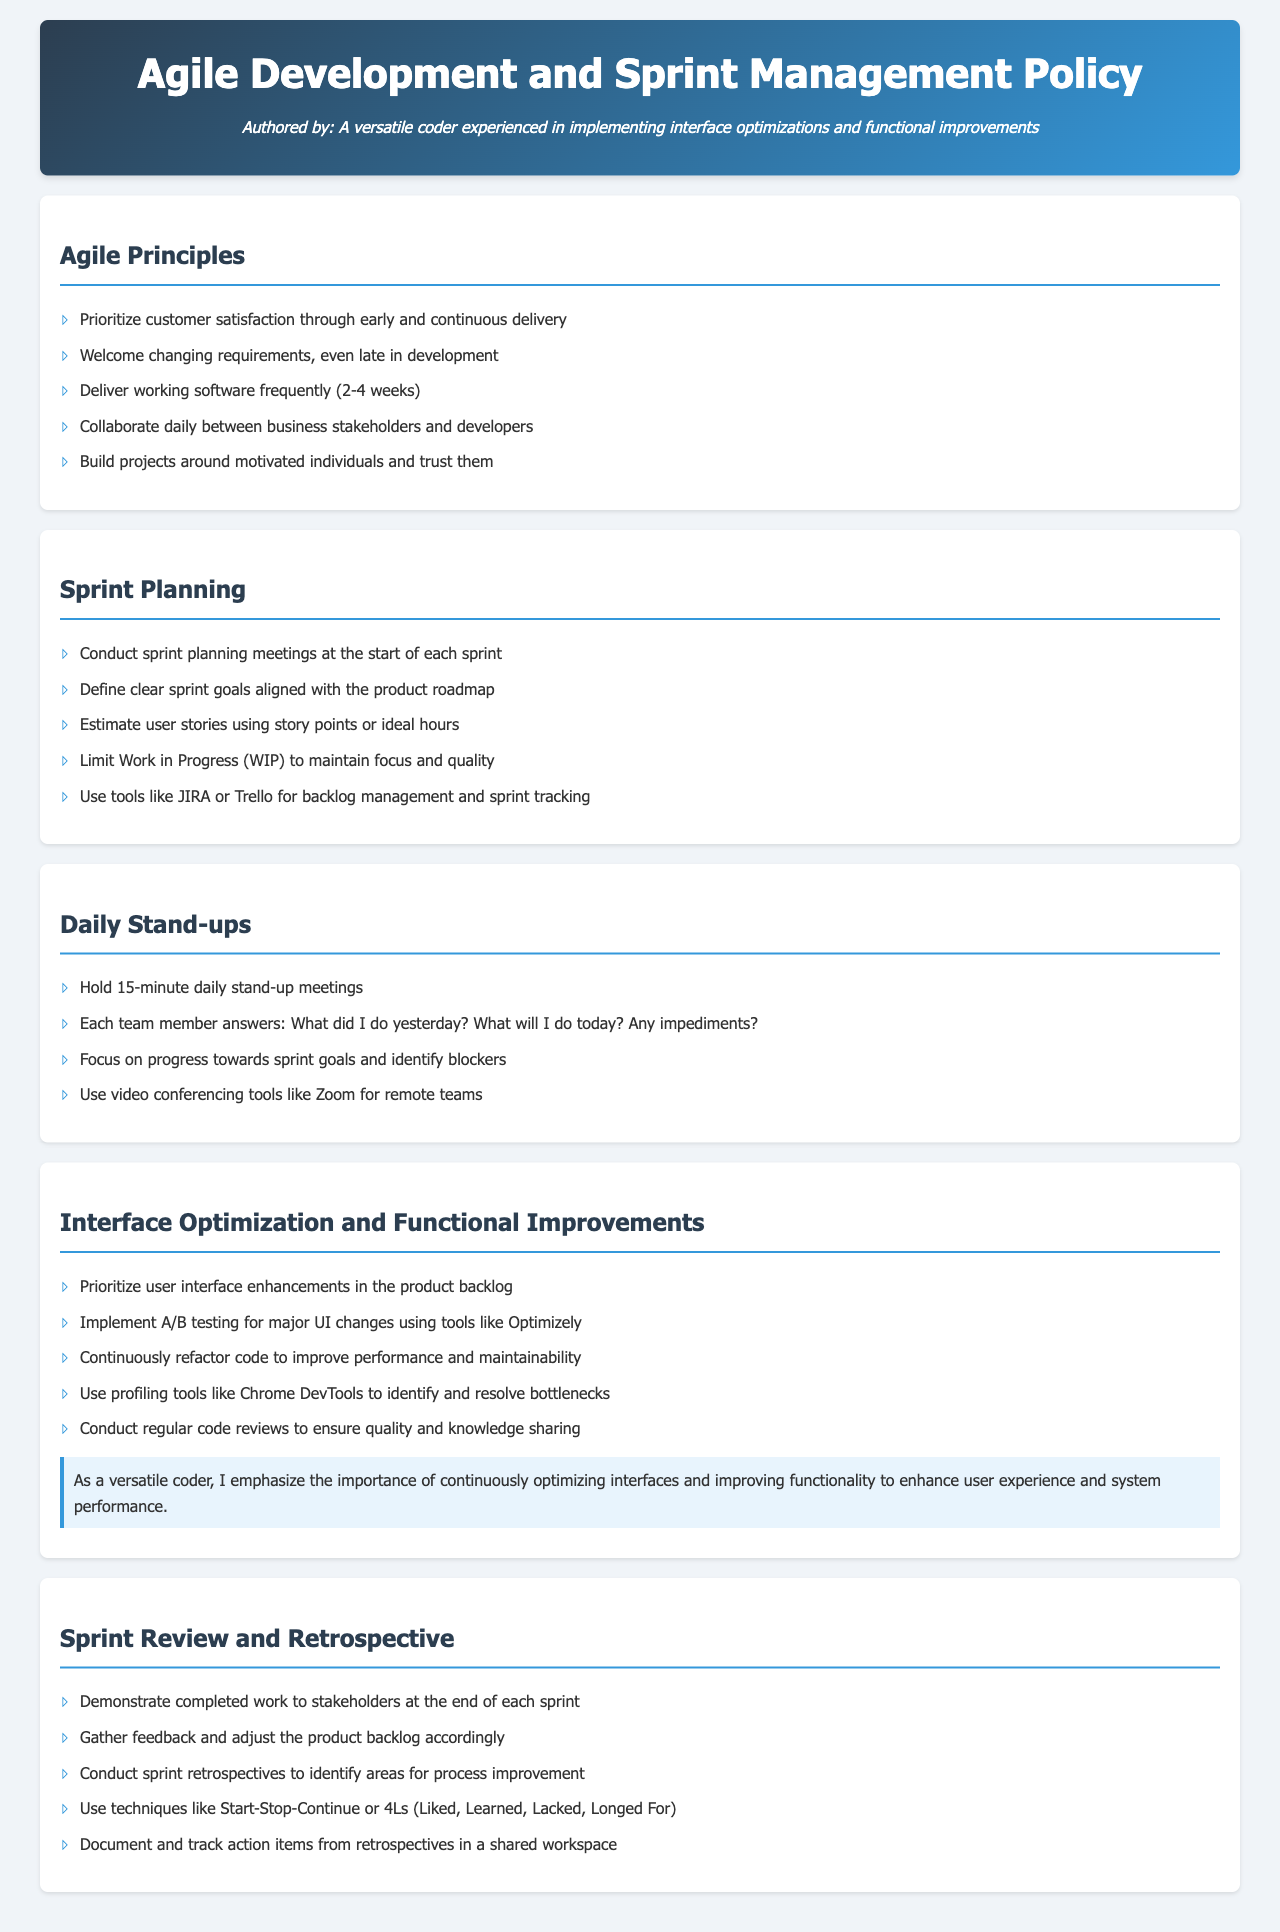What is the duration of the daily stand-up meetings? The document states that daily stand-up meetings should last for 15 minutes.
Answer: 15 minutes How often should working software be delivered? According to the Agile Principles, working software should be delivered frequently, specifically every 2-4 weeks.
Answer: 2-4 weeks What tools are suggested for backlog management? The document mentions using tools like JIRA or Trello for managing the backlog and tracking sprints.
Answer: JIRA or Trello What is the main emphasis in the section about interface optimization? The highlighted section stresses the importance of continuously optimizing interfaces to enhance user experience and system performance.
Answer: Continuously optimizing interfaces What technique is recommended for sprint retrospectives? The document suggests using techniques such as Start-Stop-Continue or 4Ls (Liked, Learned, Lacked, Longed For) during retrospectives.
Answer: Start-Stop-Continue or 4Ls 